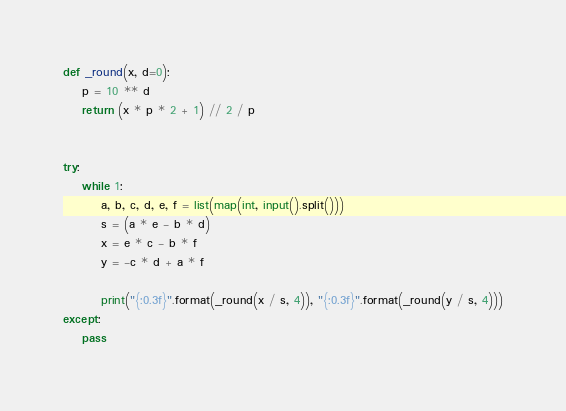<code> <loc_0><loc_0><loc_500><loc_500><_Python_>def _round(x, d=0):
    p = 10 ** d
    return (x * p * 2 + 1) // 2 / p


try:
    while 1:
        a, b, c, d, e, f = list(map(int, input().split()))
        s = (a * e - b * d)
        x = e * c - b * f
        y = -c * d + a * f

        print("{:0.3f}".format(_round(x / s, 4)), "{:0.3f}".format(_round(y / s, 4)))
except:
    pass</code> 